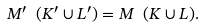<formula> <loc_0><loc_0><loc_500><loc_500>M ^ { \prime } \ ( K ^ { \prime } \cup L ^ { \prime } ) = M \ ( K \cup L ) .</formula> 